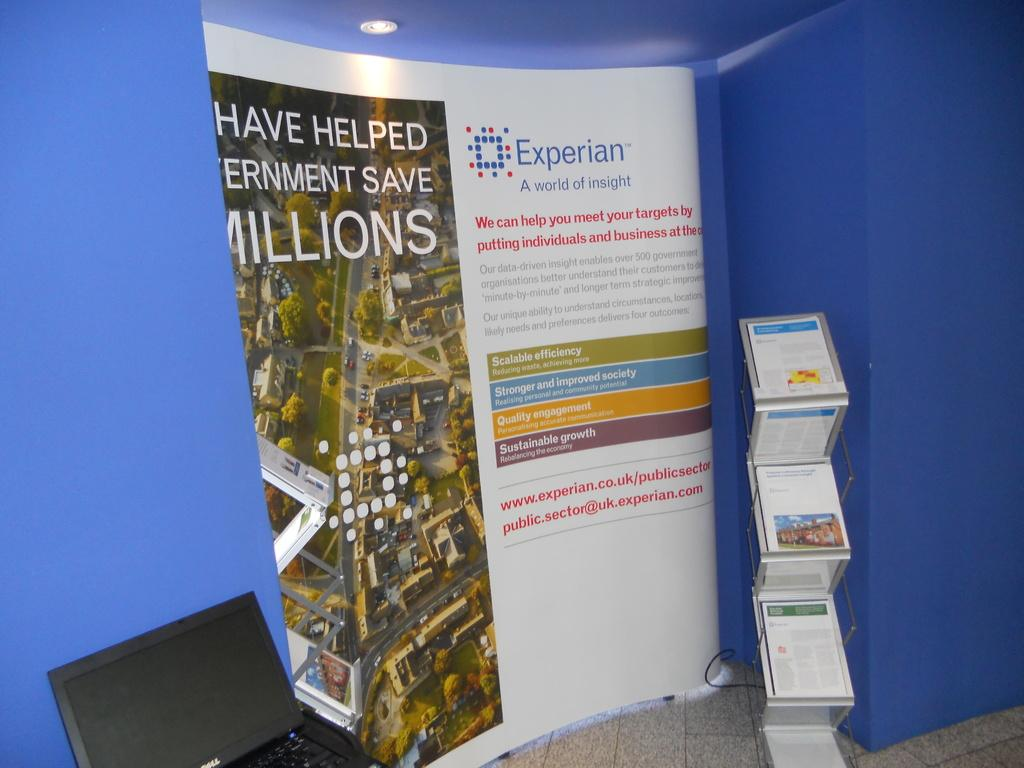<image>
Provide a brief description of the given image. A large ad has the Experian logo on it and is in front of a blue background. 